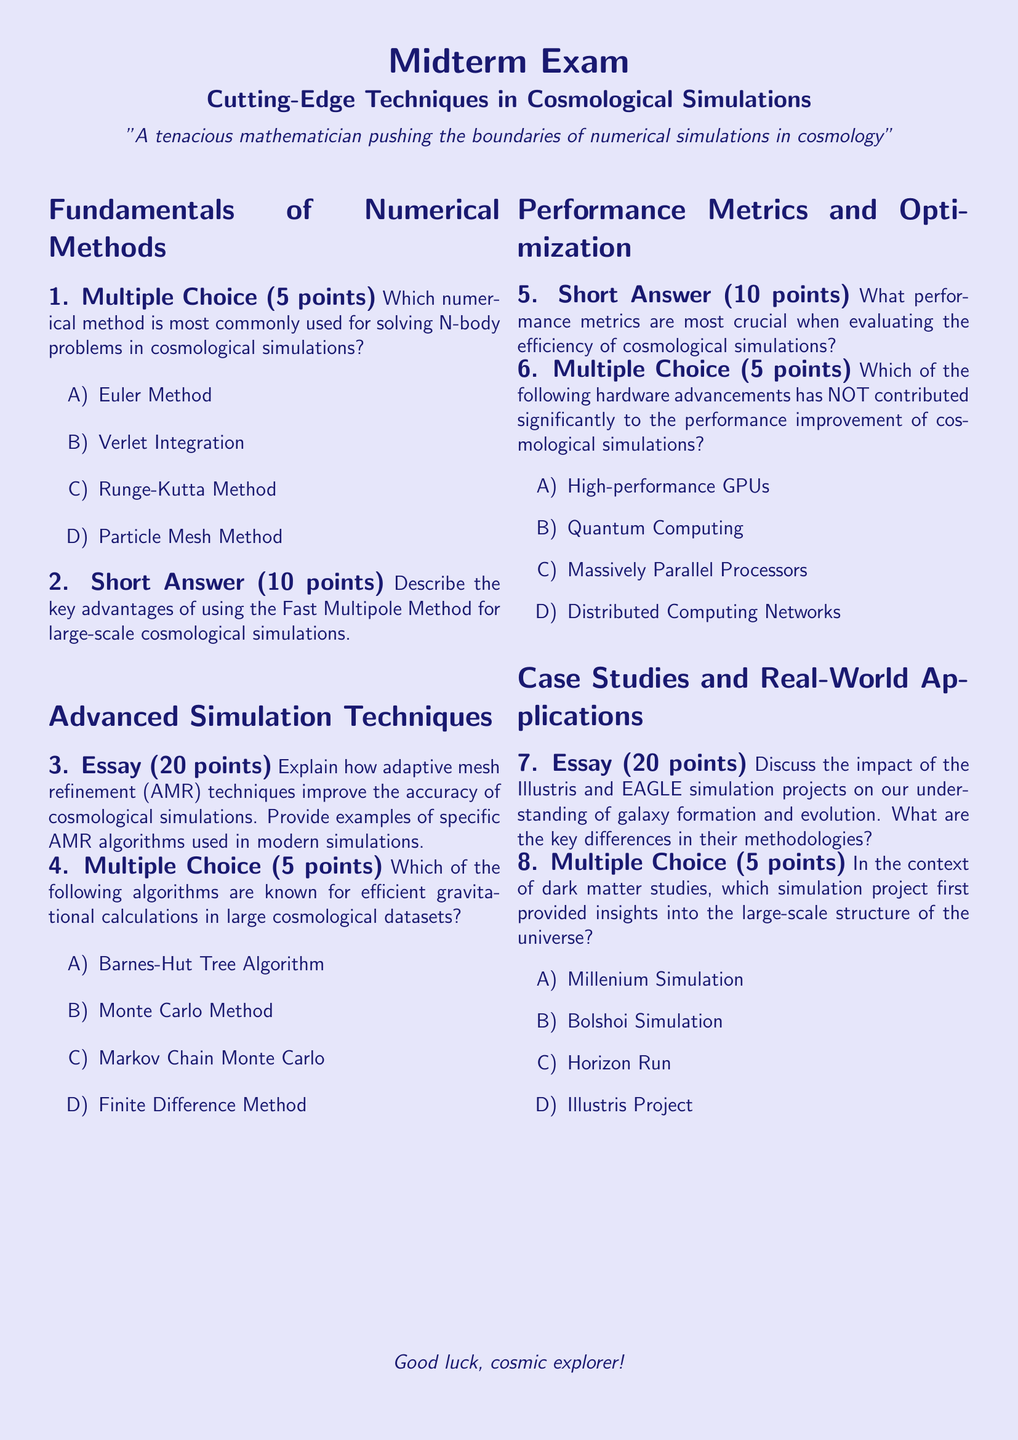What is the title of the exam? The title is presented at the top of the document and clearly states the content covered in that exam.
Answer: Cutting-Edge Techniques in Cosmological Simulations What is the point value for each multiple-choice question? The document specifies that each multiple-choice question is worth a certain number of points for the exam.
Answer: 5 points How many points are awarded for the essay questions? The document lists the point values for different types of questions indicating the weighting of the essay type.
Answer: 20 points What numerical method is most commonly used for solving N-body problems? The document includes a multiple-choice question that identifies this numerical method as part of the curriculum in cosmological simulations.
Answer: Verlet Integration Which algorithm is known for efficient gravitational calculations? The document includes a multiple-choice question specifically asking about algorithms used in cosmology, indicating one such choice.
Answer: Barnes-Hut Tree Algorithm What are the key differences being compared in the essay about the Illustris and EAGLE simulation projects? The essay question prompts students to identify differences between two specific simulation methodologies.
Answer: Methodologies What color is used for the page background? The document specifies the color used for the page background in the settings and style section.
Answer: Stardust What is the total number of sections in the exam? The document is organized into clear sections, and counting them will reveal the structure of the exam.
Answer: 3 sections 